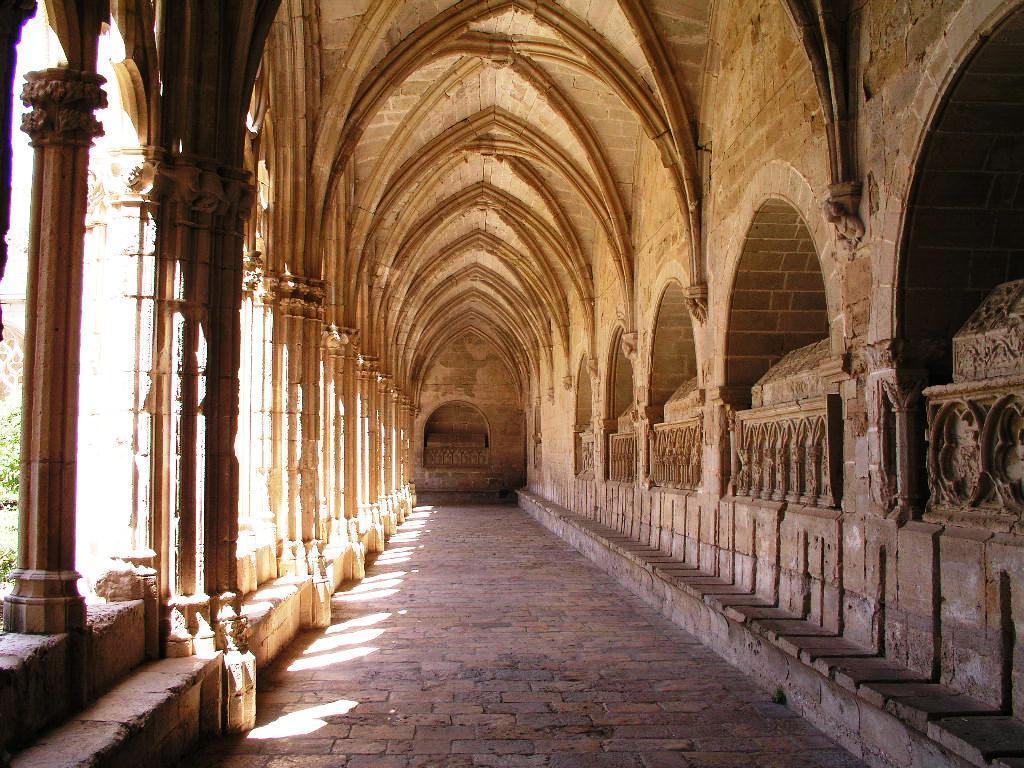Describe this image in one or two sentences. This picture shows the inner view of a Reial monestir de Santes crew and some trees. 